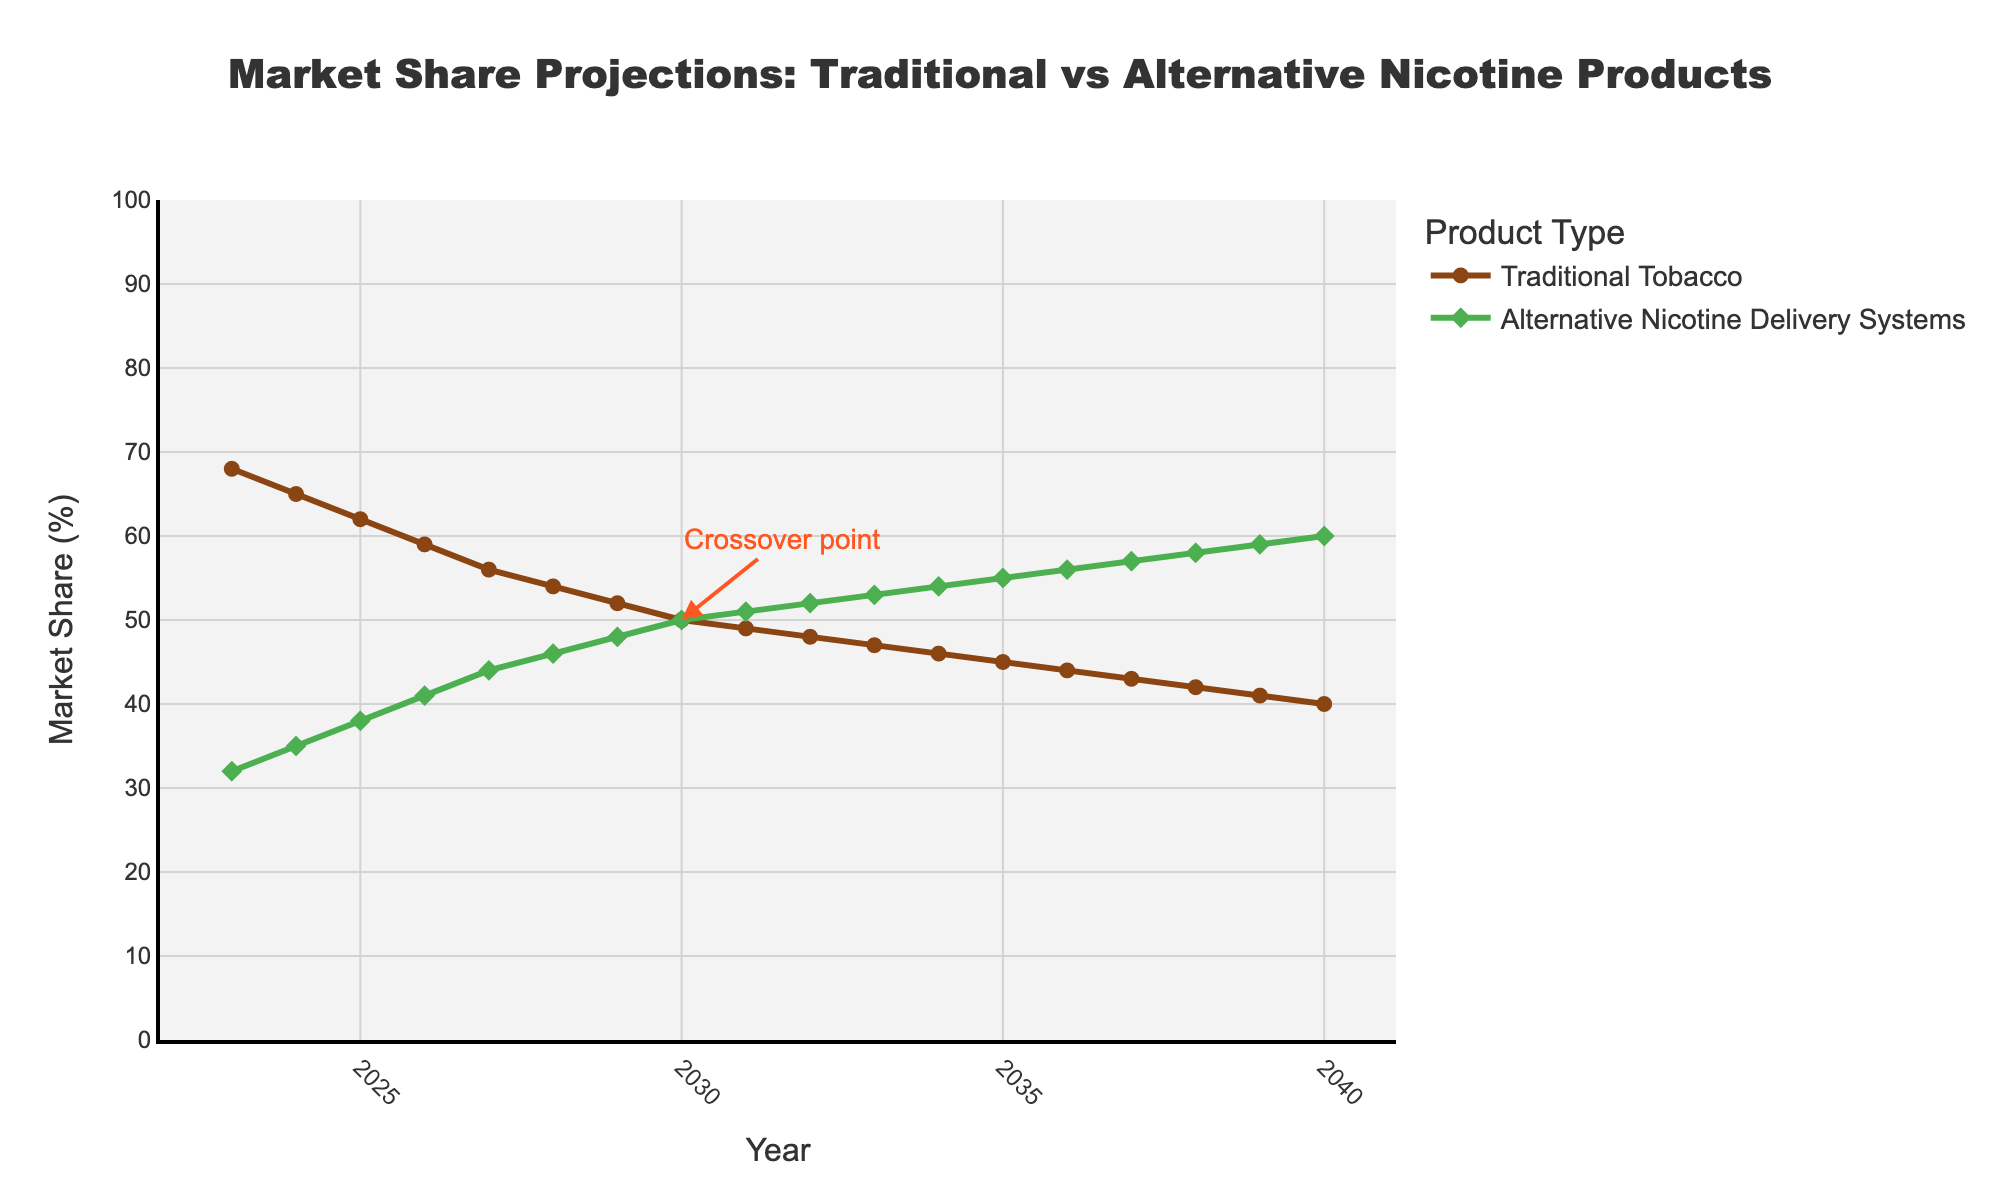Which year shows Traditional Tobacco and Alternative Nicotine Delivery Systems having equal market share? The crossover point annotation on the figure clearly shows that in 2030, both Traditional Tobacco and Alternative Nicotine Delivery Systems have a market share of 50%.
Answer: 2030 By how many percentage points does the market share of Traditional Tobacco decrease from 2023 to 2040? In 2023, the market share of Traditional Tobacco is 68%, and in 2040, it is 40%. The difference is calculated as 68% - 40%.
Answer: 28% How does the market share of Alternative Nicotine Delivery Systems in 2026 compare to that in 2036? The market share of Alternative Nicotine Delivery Systems in 2026 is 41% and in 2036 it is 56%. Comparing the two, 41% is less than 56%.
Answer: Less In which year does Alternative Nicotine Delivery Systems surpass Traditional Tobacco in market share for the first time? The figure shows that Alternative Nicotine Delivery Systems exceed the market share of Traditional Tobacco starting in 2031, where the market share for Traditional Tobacco is 49% and for Alternative Nicotine Delivery Systems is 51%.
Answer: 2031 What is the total market share percentage for both categories in 2030? For 2030, the market share of Traditional Tobacco is 50%, and the market share of Alternative Nicotine Delivery Systems is also 50%. Adding them together gives 50% + 50%.
Answer: 100% What is the average market share of Alternative Nicotine Delivery Systems between 2023 and 2040? Sum the market shares of Alternative Nicotine Delivery Systems for each year from 2023 to 2040 and divide by the number of years (18). (32+35+38+41+44+46+48+50+51+52+53+54+55+56+57+58+59+60)/18 = 48.44%
Answer: 48.44% Compare the market share of Traditional Tobacco in the first and the last year. Which is higher and by how much? In 2023, the market share of Traditional Tobacco is 68%, and in 2040, it is 40%. Comparing these, 68% is higher by a difference of 68% - 40%.
Answer: 28% higher in 2023 What trend is observed for Traditional Tobacco products from 2023 to 2040? The market share of Traditional Tobacco shows a declining trend from 68% in 2023 to 40% in 2040. The line graph depicting this trend consistently slopes downwards.
Answer: Declining Calculate the median market share of Traditional Tobacco from 2023 to 2040. To find the median, list the Traditional Tobacco market share percentages in order: 68, 65, 62, 59, 56, 54, 52, 50, 49, 48, 47, 46, 45, 44, 43, 42, 41, 40. Since there are 18 data points, the median is the average of the 9th and 10th values: (49+48)/2.
Answer: 48.5% 